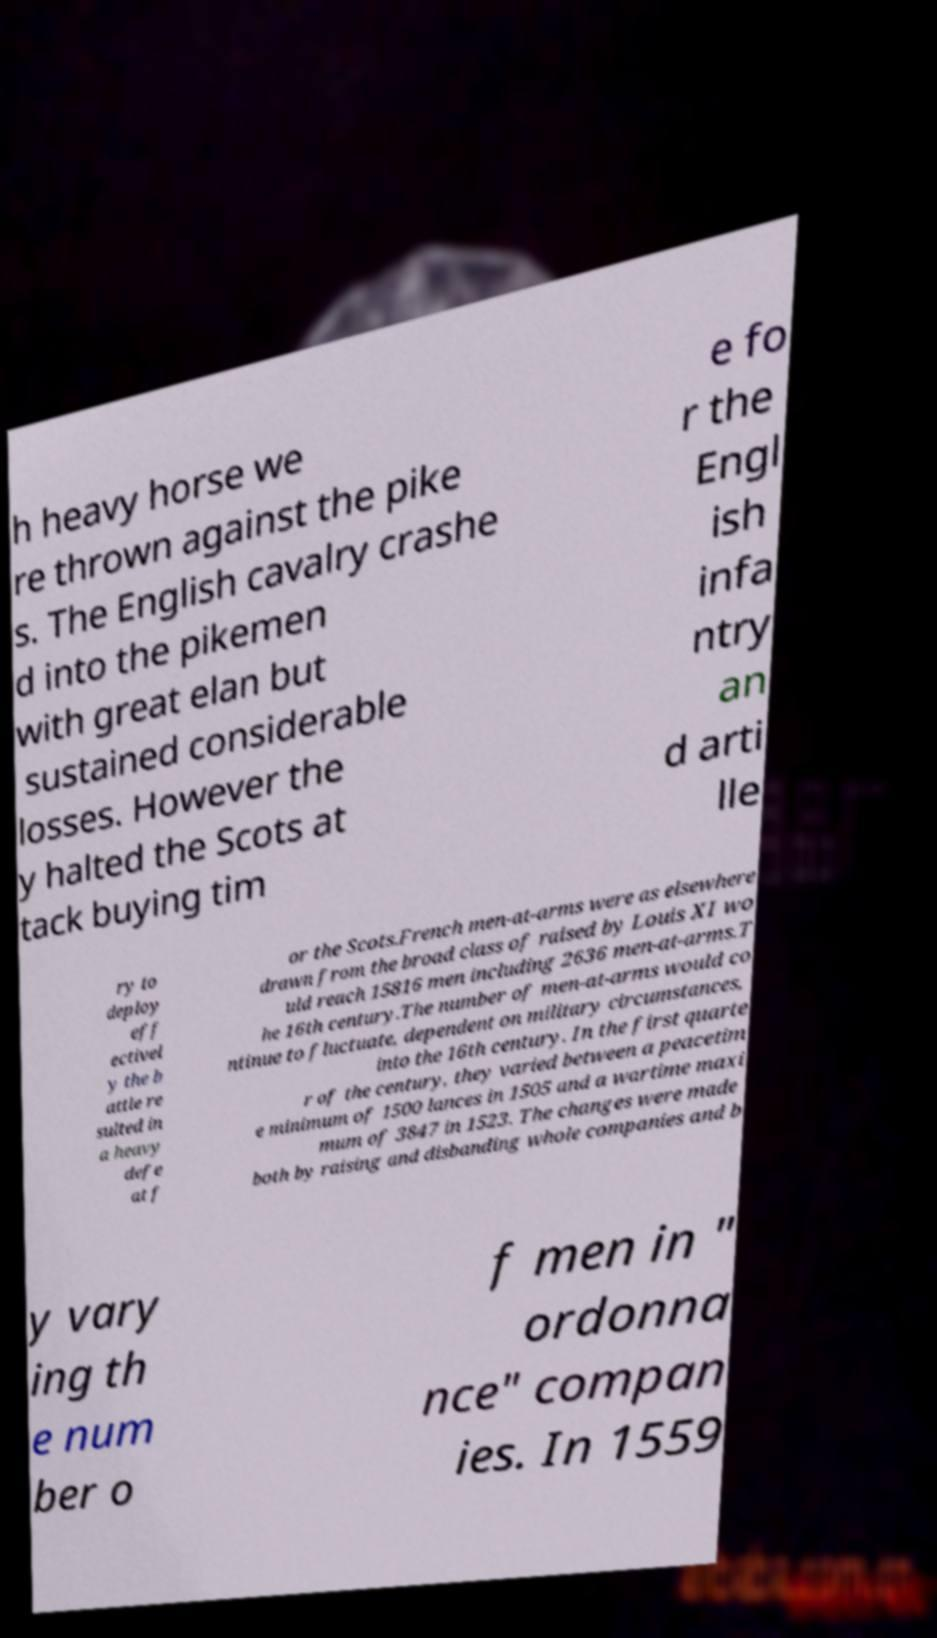What messages or text are displayed in this image? I need them in a readable, typed format. h heavy horse we re thrown against the pike s. The English cavalry crashe d into the pikemen with great elan but sustained considerable losses. However the y halted the Scots at tack buying tim e fo r the Engl ish infa ntry an d arti lle ry to deploy eff ectivel y the b attle re sulted in a heavy defe at f or the Scots.French men-at-arms were as elsewhere drawn from the broad class of raised by Louis XI wo uld reach 15816 men including 2636 men-at-arms.T he 16th century.The number of men-at-arms would co ntinue to fluctuate, dependent on military circumstances, into the 16th century. In the first quarte r of the century, they varied between a peacetim e minimum of 1500 lances in 1505 and a wartime maxi mum of 3847 in 1523. The changes were made both by raising and disbanding whole companies and b y vary ing th e num ber o f men in " ordonna nce" compan ies. In 1559 